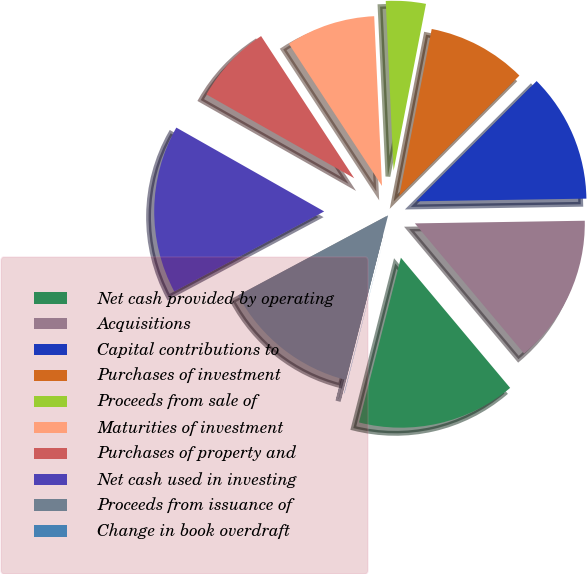Convert chart to OTSL. <chart><loc_0><loc_0><loc_500><loc_500><pie_chart><fcel>Net cash provided by operating<fcel>Acquisitions<fcel>Capital contributions to<fcel>Purchases of investment<fcel>Proceeds from sale of<fcel>Maturities of investment<fcel>Purchases of property and<fcel>Net cash used in investing<fcel>Proceeds from issuance of<fcel>Change in book overdraft<nl><fcel>15.08%<fcel>14.14%<fcel>12.26%<fcel>9.44%<fcel>3.79%<fcel>8.5%<fcel>7.56%<fcel>16.02%<fcel>13.2%<fcel>0.03%<nl></chart> 